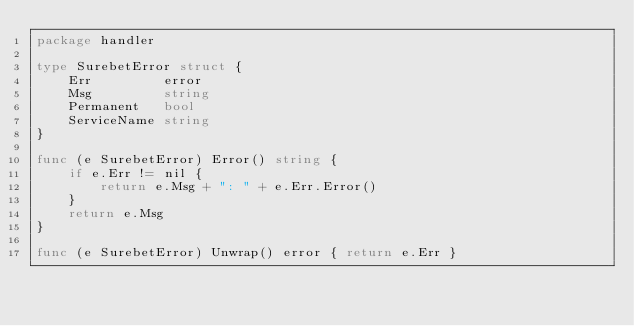<code> <loc_0><loc_0><loc_500><loc_500><_Go_>package handler

type SurebetError struct {
	Err         error
	Msg         string
	Permanent   bool
	ServiceName string
}

func (e SurebetError) Error() string {
	if e.Err != nil {
		return e.Msg + ": " + e.Err.Error()
	}
	return e.Msg
}

func (e SurebetError) Unwrap() error { return e.Err }
</code> 